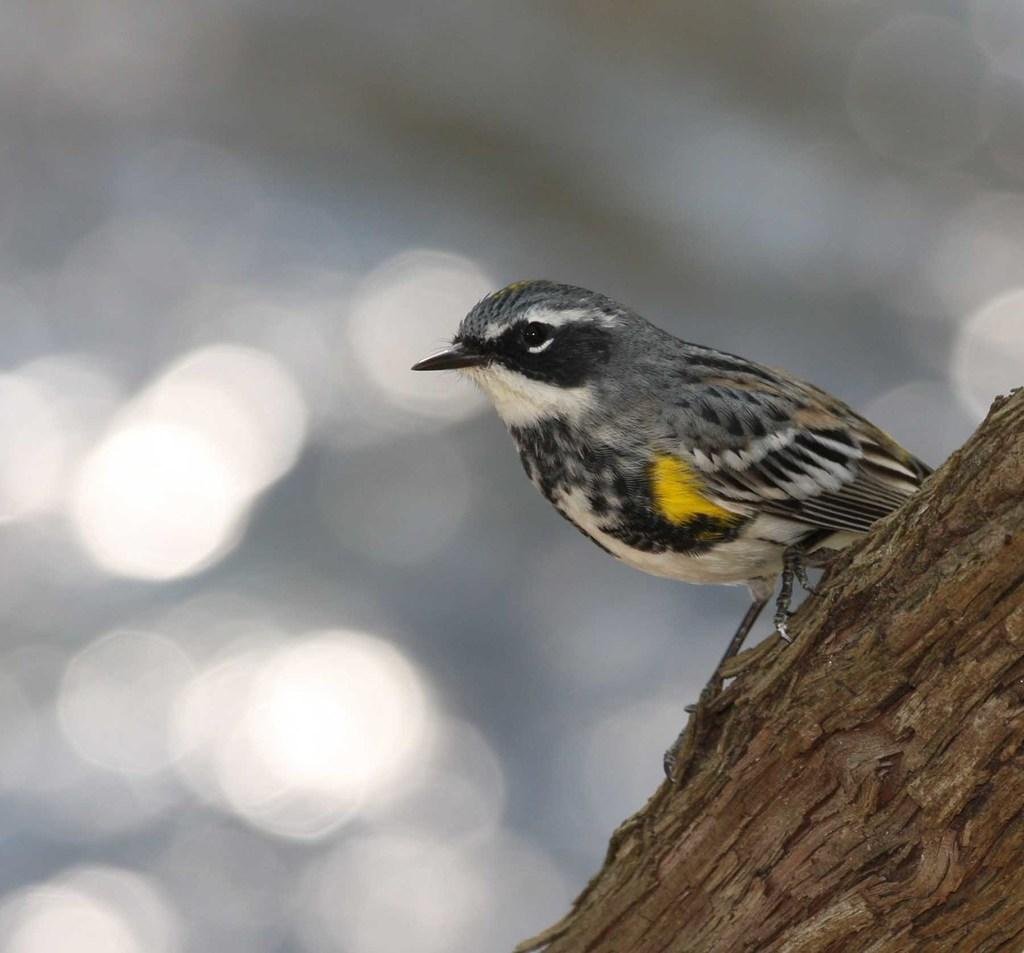What type of animal can be seen in the image? There is a bird in the image. Where is the bird located? The bird is on a trunk. Can you describe the background of the image? The background of the image is not clear. What is the bird's suggestion for the next adventure in the image? There is no indication of the bird making a suggestion in the image. 